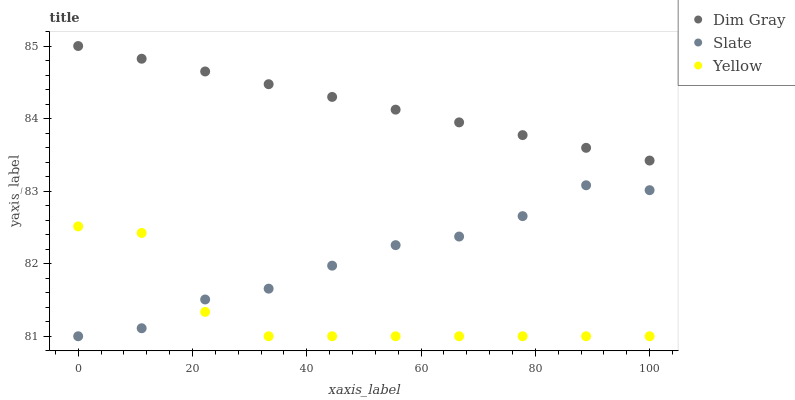Does Yellow have the minimum area under the curve?
Answer yes or no. Yes. Does Dim Gray have the maximum area under the curve?
Answer yes or no. Yes. Does Dim Gray have the minimum area under the curve?
Answer yes or no. No. Does Yellow have the maximum area under the curve?
Answer yes or no. No. Is Dim Gray the smoothest?
Answer yes or no. Yes. Is Yellow the roughest?
Answer yes or no. Yes. Is Yellow the smoothest?
Answer yes or no. No. Is Dim Gray the roughest?
Answer yes or no. No. Does Slate have the lowest value?
Answer yes or no. Yes. Does Dim Gray have the lowest value?
Answer yes or no. No. Does Dim Gray have the highest value?
Answer yes or no. Yes. Does Yellow have the highest value?
Answer yes or no. No. Is Yellow less than Dim Gray?
Answer yes or no. Yes. Is Dim Gray greater than Yellow?
Answer yes or no. Yes. Does Slate intersect Yellow?
Answer yes or no. Yes. Is Slate less than Yellow?
Answer yes or no. No. Is Slate greater than Yellow?
Answer yes or no. No. Does Yellow intersect Dim Gray?
Answer yes or no. No. 